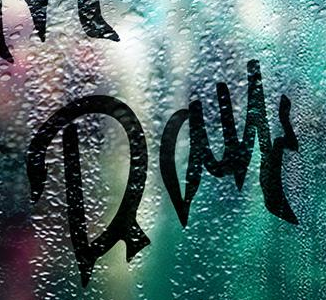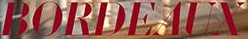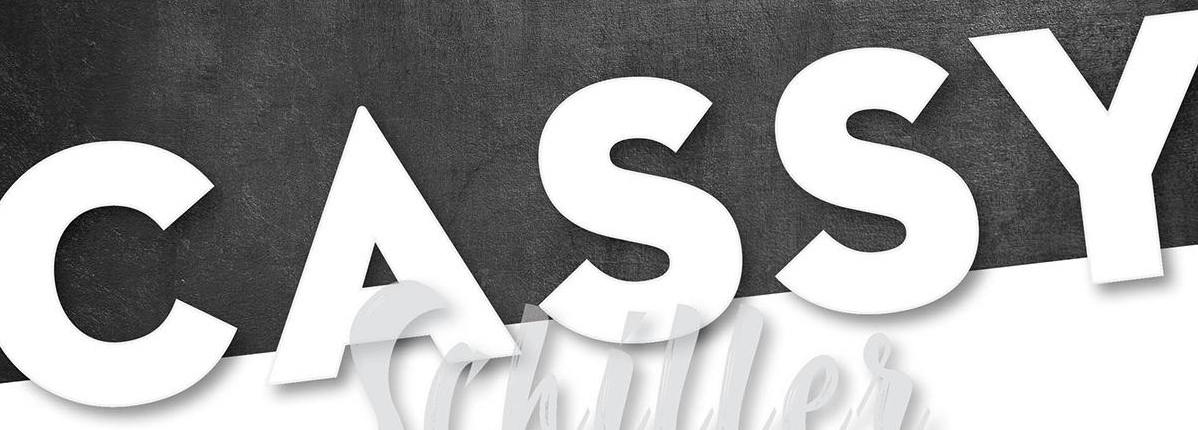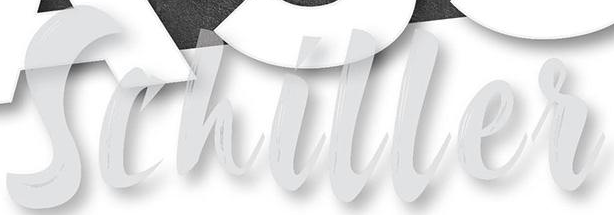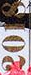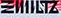What text appears in these images from left to right, separated by a semicolon? Day; BORDEAUX; CASSY; Schiller; 2018; ΞIIIILTZ 